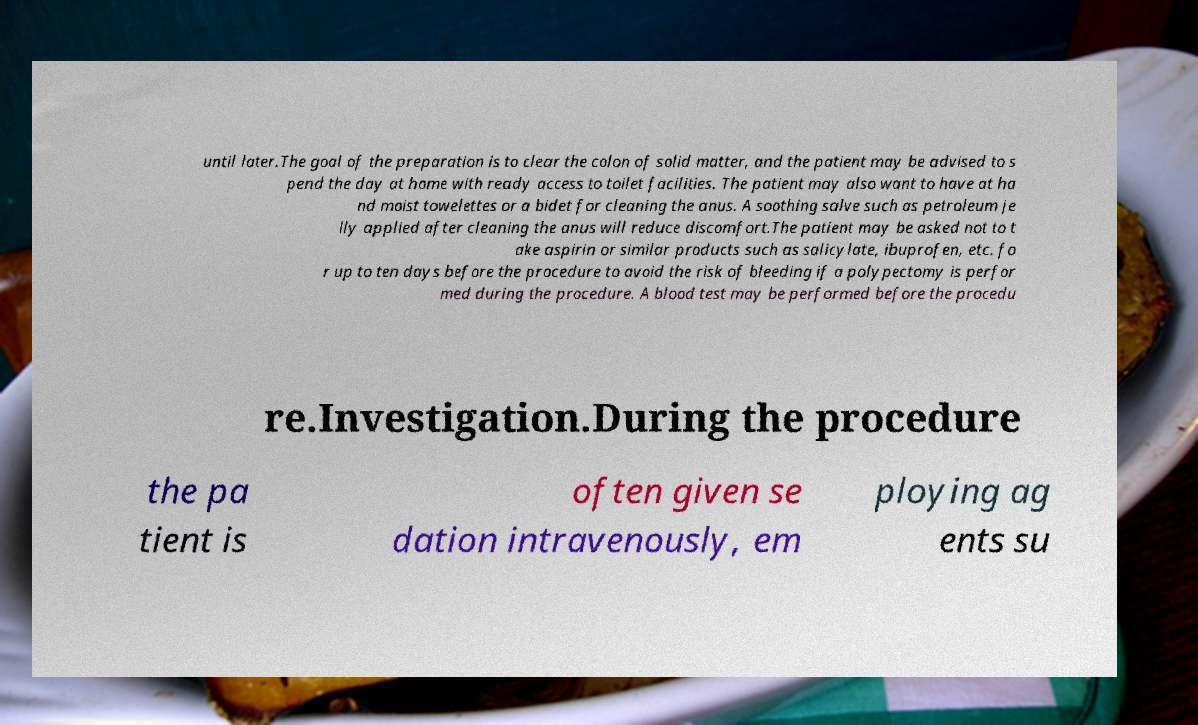What messages or text are displayed in this image? I need them in a readable, typed format. until later.The goal of the preparation is to clear the colon of solid matter, and the patient may be advised to s pend the day at home with ready access to toilet facilities. The patient may also want to have at ha nd moist towelettes or a bidet for cleaning the anus. A soothing salve such as petroleum je lly applied after cleaning the anus will reduce discomfort.The patient may be asked not to t ake aspirin or similar products such as salicylate, ibuprofen, etc. fo r up to ten days before the procedure to avoid the risk of bleeding if a polypectomy is perfor med during the procedure. A blood test may be performed before the procedu re.Investigation.During the procedure the pa tient is often given se dation intravenously, em ploying ag ents su 